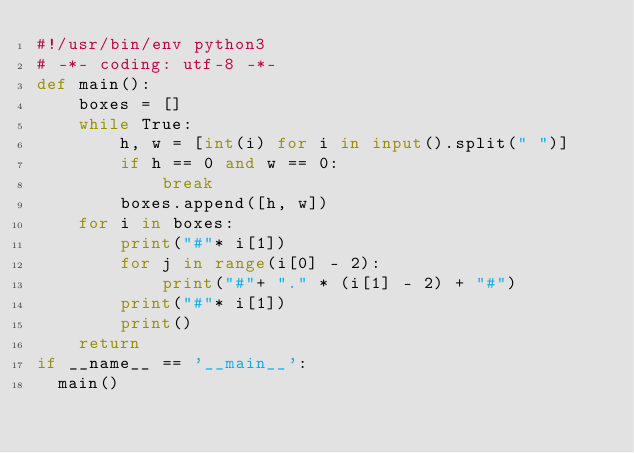<code> <loc_0><loc_0><loc_500><loc_500><_Python_>#!/usr/bin/env python3
# -*- coding: utf-8 -*-
def main():
	boxes = []
	while True:
		h, w = [int(i) for i in input().split(" ")]
		if h == 0 and w == 0:
			break
		boxes.append([h, w])
	for i in boxes:
		print("#"* i[1])
		for j in range(i[0] - 2):
			print("#"+ "." * (i[1] - 2) + "#")
		print("#"* i[1])
		print()
	return
if __name__ == '__main__':
  main()</code> 